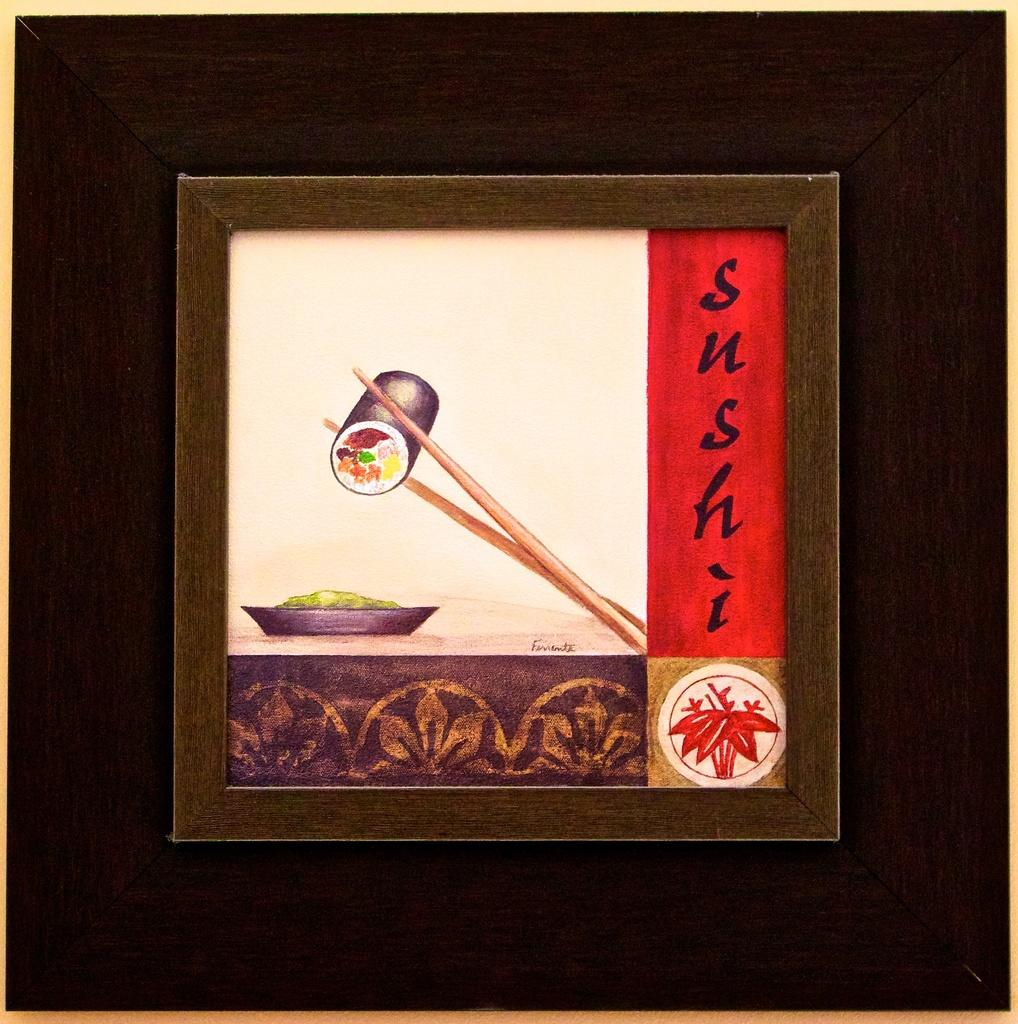<image>
Provide a brief description of the given image. Photograph of chopsticks holding sushi and the word SUSHi on the side. 